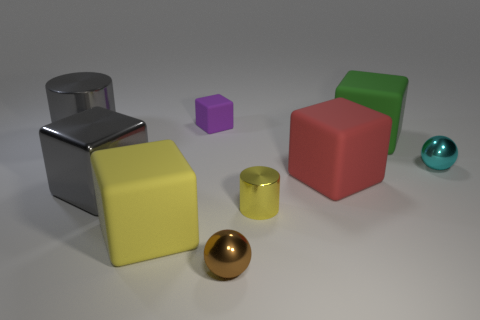What do the sizes of these objects imply? The variety of sizes among these objects creates an interesting visual array and demonstrates the concept of scale. The smallest object appears to be the purple cube, which, compared to the largest object, the silver cylinder, suggests a study in proportion. Such differences in size could imply a hierarchy, indicate depth, or simply serve to contrast and emphasize each item's distinct shape.  Are there any patterns or themes that can be observed among these items? A theme that emerges upon closer examination of the image is the emphasis on basic geometric forms: spheres, cylinders, and cubes. This collection of shapes might represent the fundamental building blocks of visual design, and their arrangement can evoke a minimalist or educational theme, likely designed to focus on the simple beauty of geometry and color. 